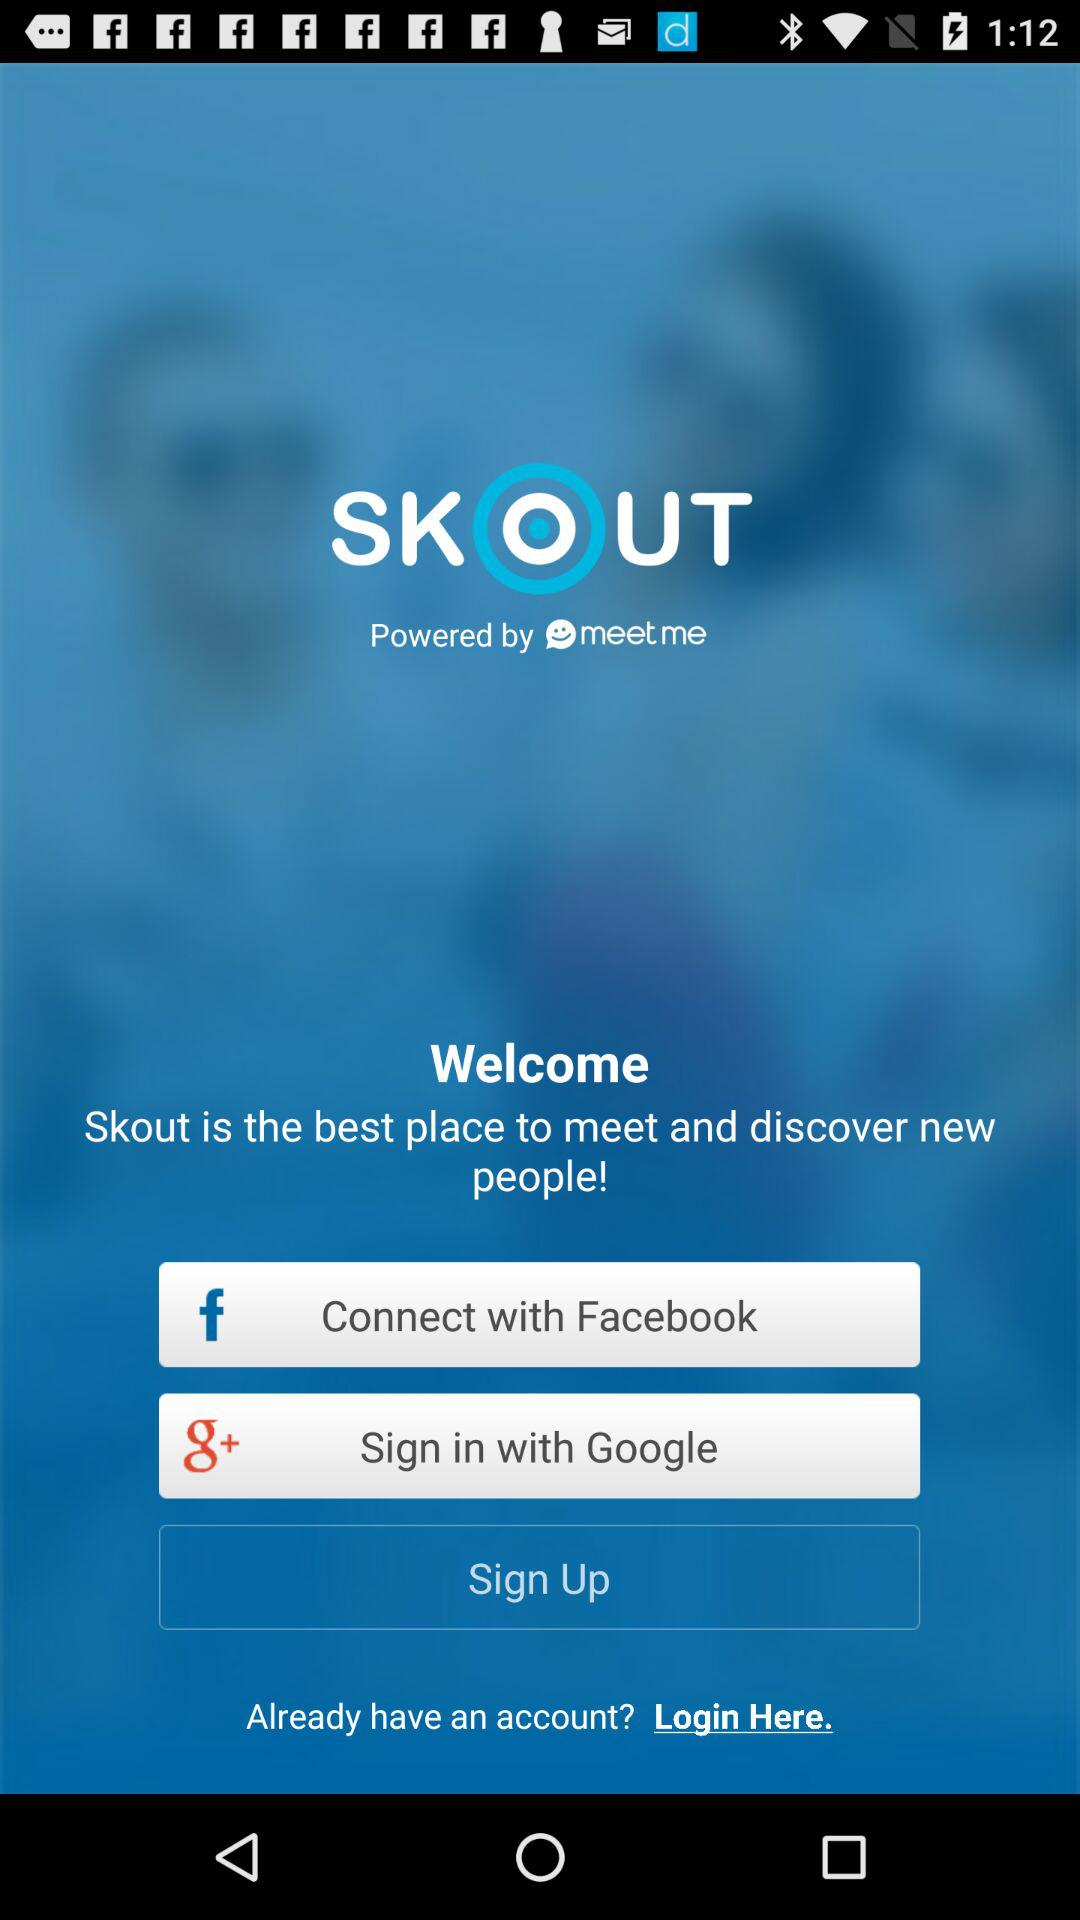Through which social apps can we sign in? You can sign in with "Facebook" and "Google". 